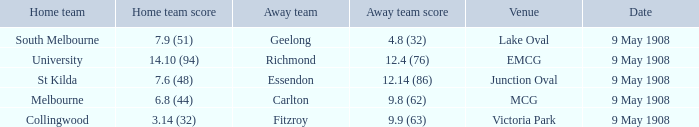Name the home team for carlton away team Melbourne. Can you give me this table as a dict? {'header': ['Home team', 'Home team score', 'Away team', 'Away team score', 'Venue', 'Date'], 'rows': [['South Melbourne', '7.9 (51)', 'Geelong', '4.8 (32)', 'Lake Oval', '9 May 1908'], ['University', '14.10 (94)', 'Richmond', '12.4 (76)', 'EMCG', '9 May 1908'], ['St Kilda', '7.6 (48)', 'Essendon', '12.14 (86)', 'Junction Oval', '9 May 1908'], ['Melbourne', '6.8 (44)', 'Carlton', '9.8 (62)', 'MCG', '9 May 1908'], ['Collingwood', '3.14 (32)', 'Fitzroy', '9.9 (63)', 'Victoria Park', '9 May 1908']]} 